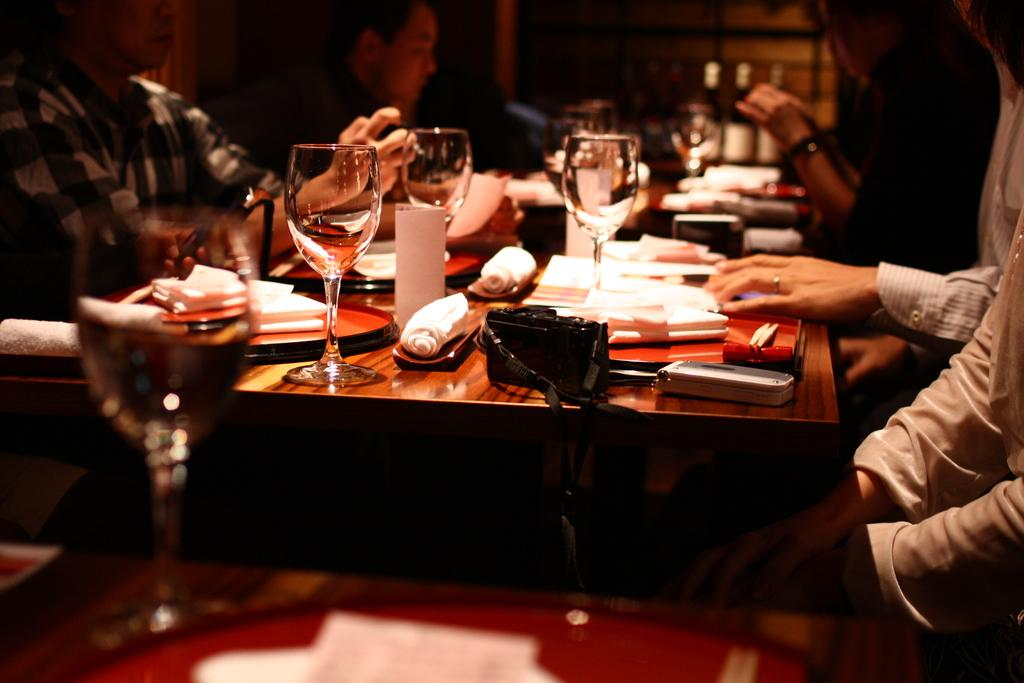What piece of furniture is present in the image? There is a table in the image. What is on the table? There is a wine glass, a napkin, a purse, a camera, and a mobile phone on the table. What objects are associated with communication or photography in the image? The camera and mobile phone are associated with communication and photography in the image. What are the people in the image doing? There are persons sitting on chairs in the image. What type of trail can be seen in the image? There is no trail present in the image; it features a table with various objects and people sitting on chairs. 